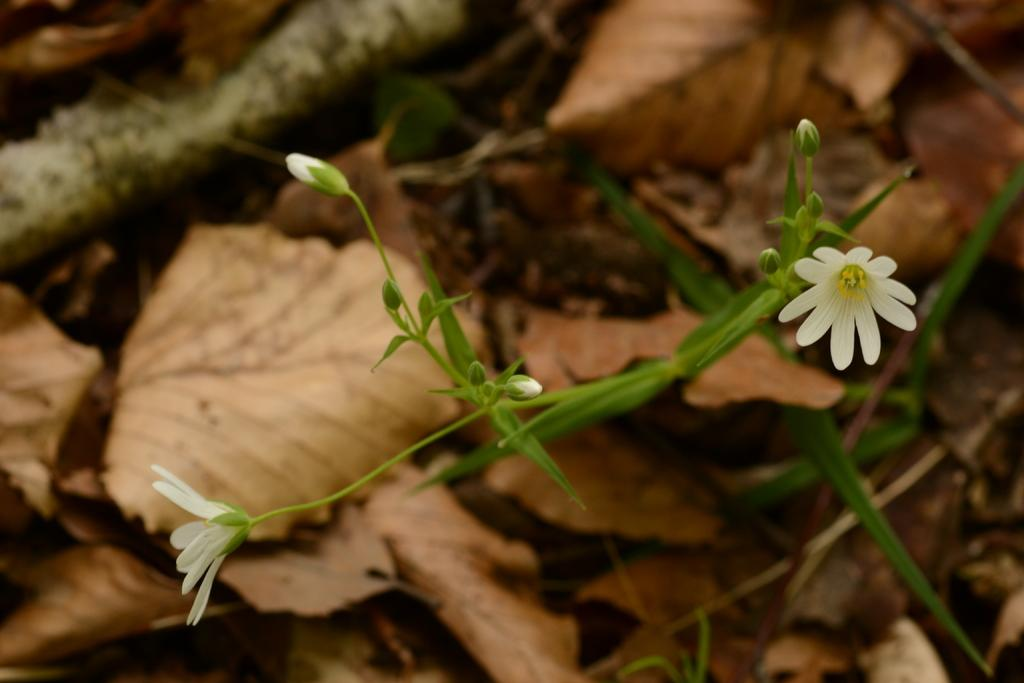What type of plants can be seen in the image? There are flowers, leaves, and grass in the image. Can you describe the vegetation in more detail? The flowers and leaves are part of the plants, while the grass is a separate type of vegetation. What is the natural environment depicted in the image? The image features a natural environment with flowers, leaves, and grass. How much salt is sprinkled on the glove in the image? There is no glove or salt present in the image; it features flowers, leaves, and grass. 